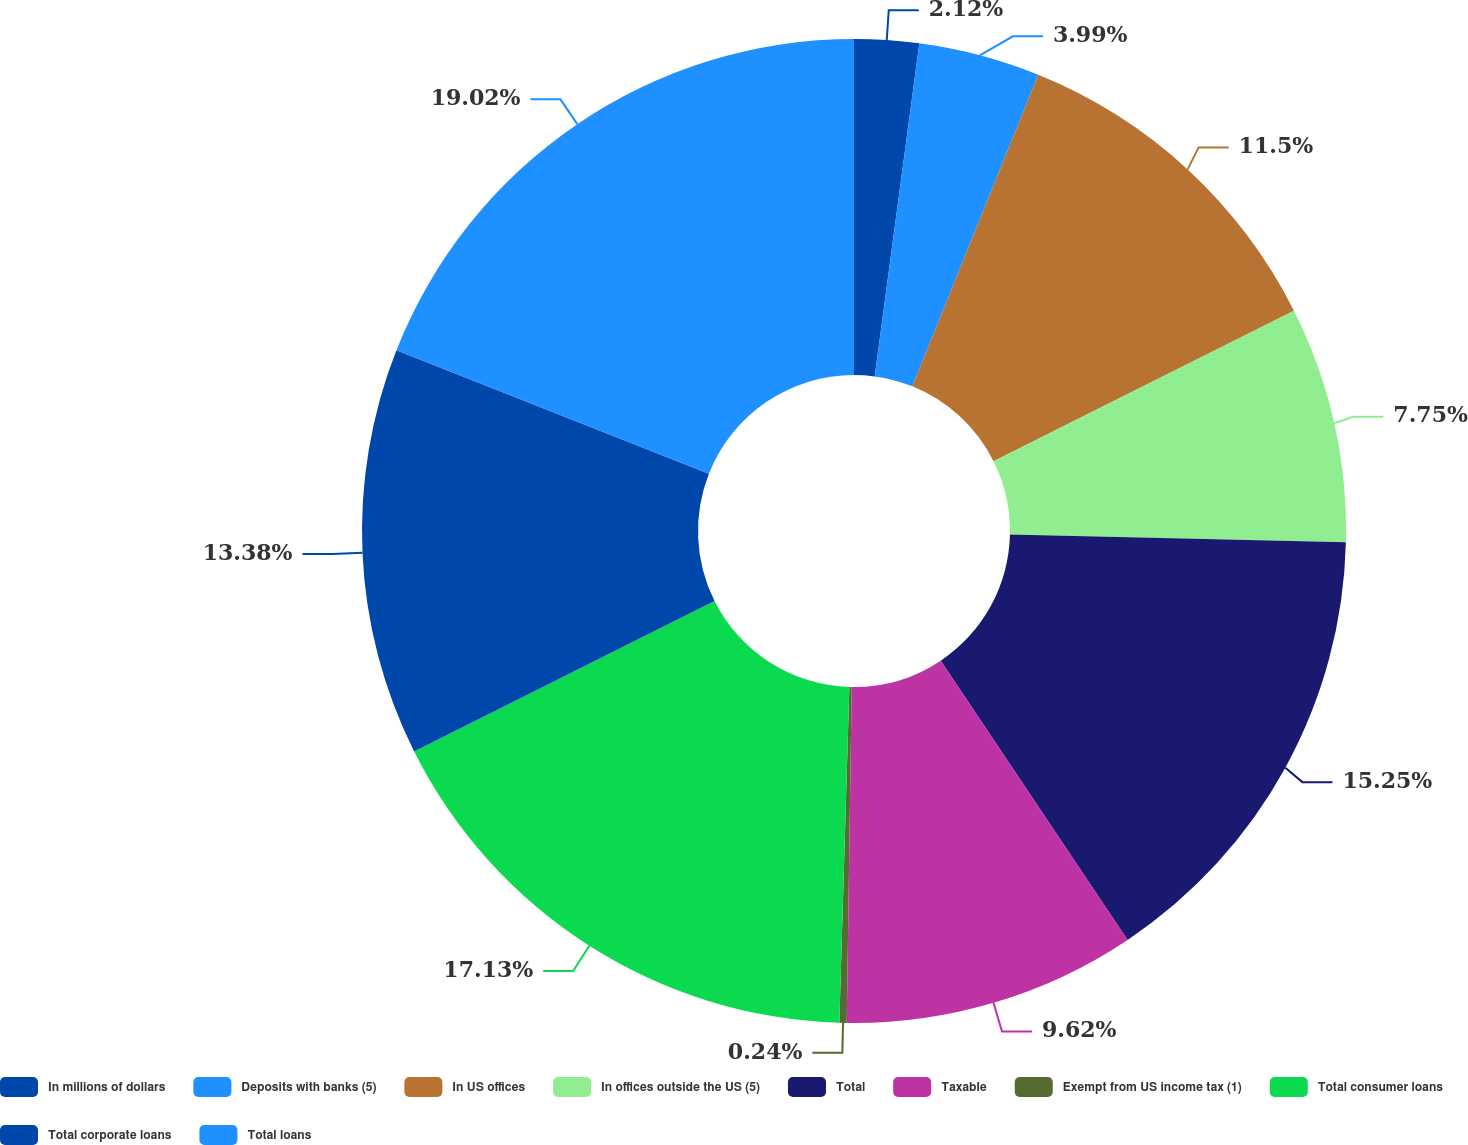Convert chart to OTSL. <chart><loc_0><loc_0><loc_500><loc_500><pie_chart><fcel>In millions of dollars<fcel>Deposits with banks (5)<fcel>In US offices<fcel>In offices outside the US (5)<fcel>Total<fcel>Taxable<fcel>Exempt from US income tax (1)<fcel>Total consumer loans<fcel>Total corporate loans<fcel>Total loans<nl><fcel>2.12%<fcel>3.99%<fcel>11.5%<fcel>7.75%<fcel>15.25%<fcel>9.62%<fcel>0.24%<fcel>17.13%<fcel>13.38%<fcel>19.01%<nl></chart> 